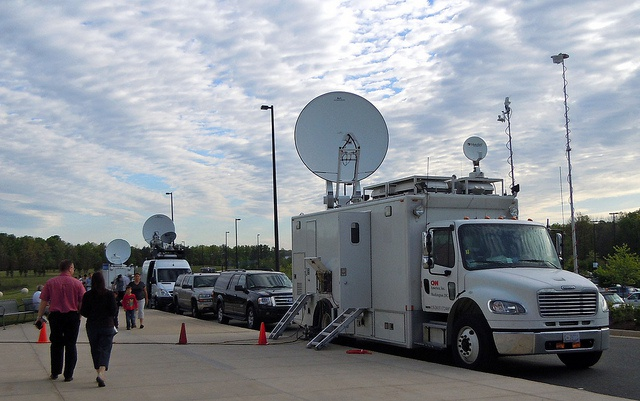Describe the objects in this image and their specific colors. I can see truck in darkgray, gray, and black tones, people in darkgray, black, maroon, gray, and purple tones, truck in darkgray, black, and gray tones, people in darkgray, black, and gray tones, and truck in darkgray, black, and gray tones in this image. 